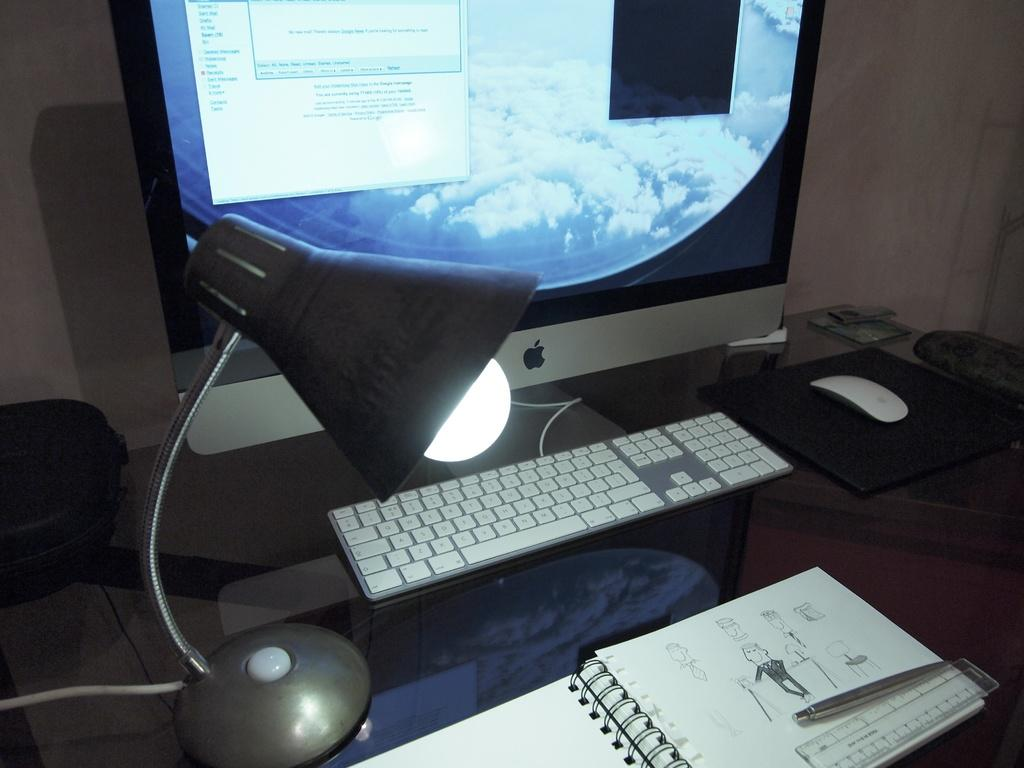Provide a one-sentence caption for the provided image. A window on the computer monitor reads, "No new mail.". 